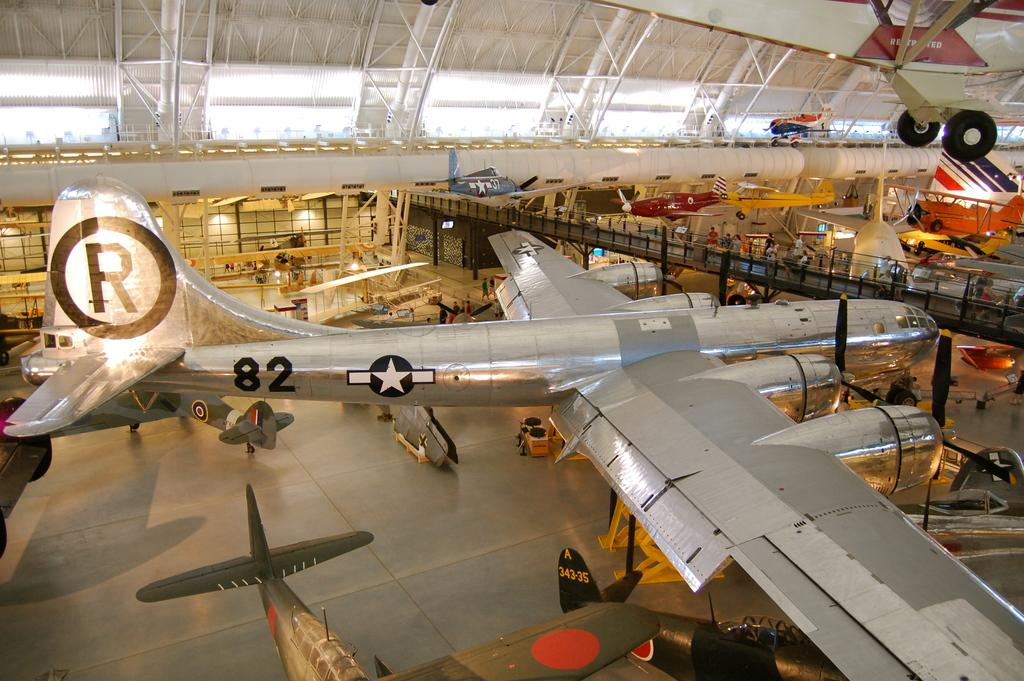<image>
Summarize the visual content of the image. A large, silver plane in a museum has a large R on the tail of it 